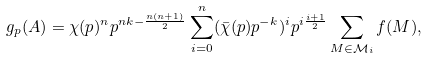<formula> <loc_0><loc_0><loc_500><loc_500>g _ { p } ( A ) = \chi ( p ) ^ { n } p ^ { n k - \frac { n ( n + 1 ) } { 2 } } \sum _ { i = 0 } ^ { n } ( \bar { \chi } ( p ) p ^ { - k } ) ^ { i } p ^ { i \frac { i + 1 } { 2 } } \sum _ { M \in { \mathcal { M } } _ { i } } f ( M ) ,</formula> 